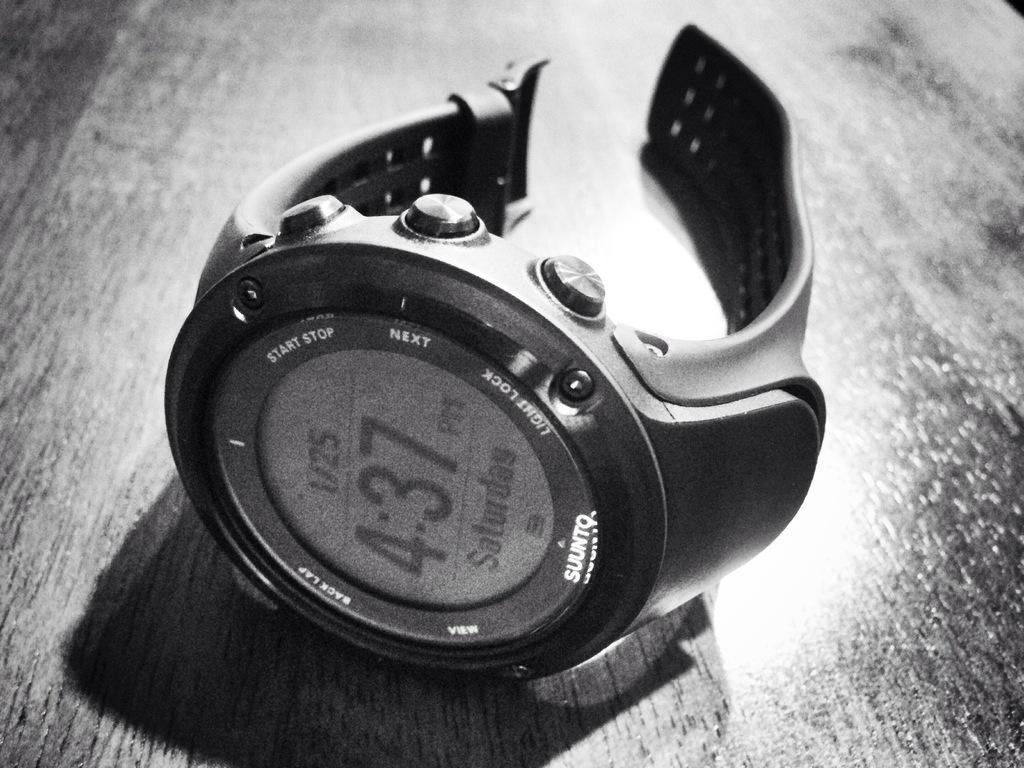<image>
Write a terse but informative summary of the picture. A watch says "SUUNTO" on the bottom of the face. 